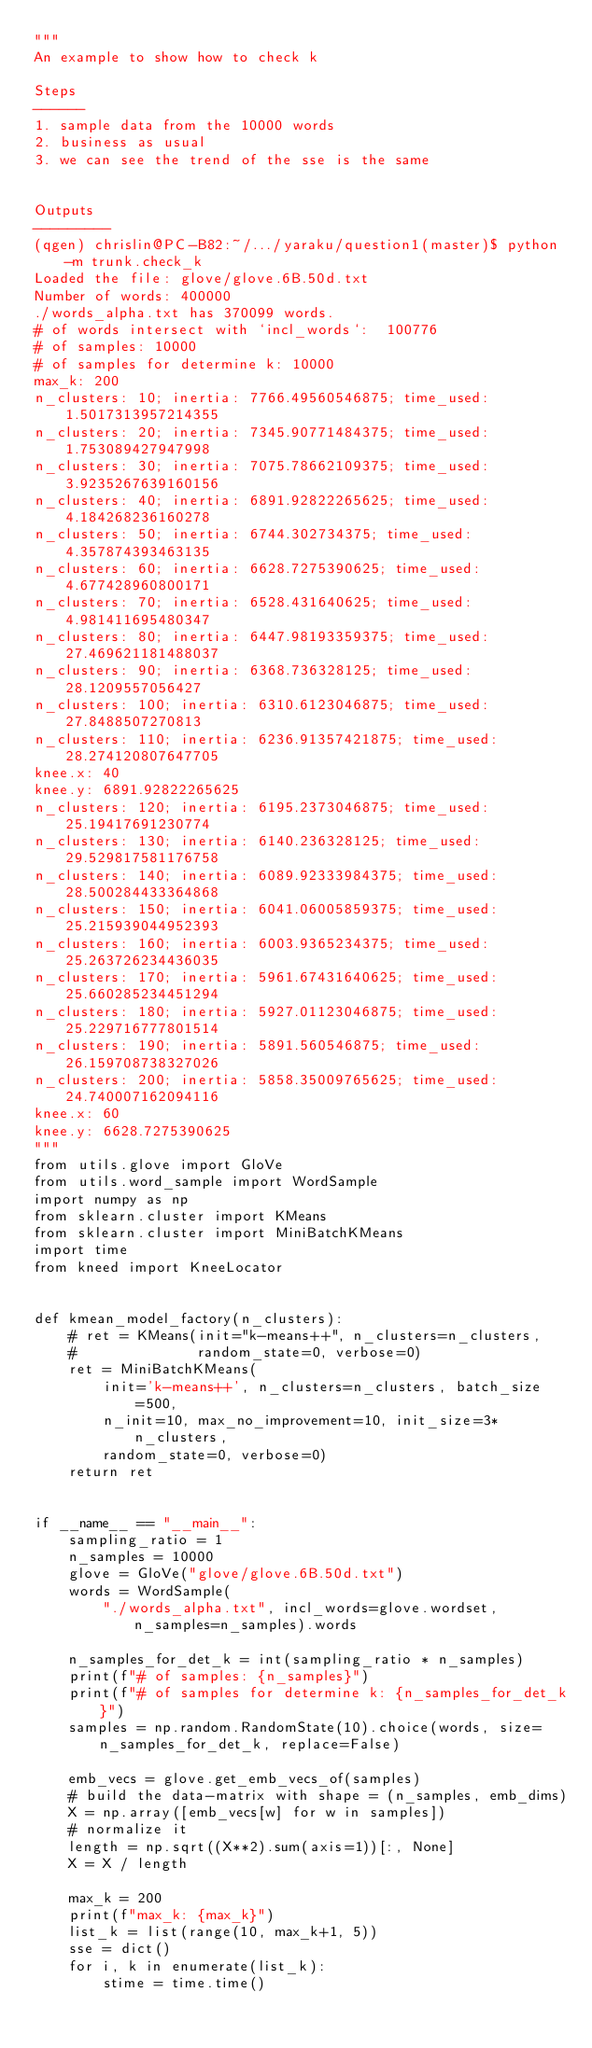<code> <loc_0><loc_0><loc_500><loc_500><_Python_>"""
An example to show how to check k

Steps
------
1. sample data from the 10000 words
2. business as usual
3. we can see the trend of the sse is the same


Outputs
---------
(qgen) chrislin@PC-B82:~/.../yaraku/question1(master)$ python -m trunk.check_k
Loaded the file: glove/glove.6B.50d.txt
Number of words: 400000
./words_alpha.txt has 370099 words.
# of words intersect with `incl_words`:  100776
# of samples: 10000
# of samples for determine k: 10000
max_k: 200
n_clusters: 10; inertia: 7766.49560546875; time_used: 1.5017313957214355
n_clusters: 20; inertia: 7345.90771484375; time_used: 1.753089427947998
n_clusters: 30; inertia: 7075.78662109375; time_used: 3.9235267639160156
n_clusters: 40; inertia: 6891.92822265625; time_used: 4.184268236160278
n_clusters: 50; inertia: 6744.302734375; time_used: 4.357874393463135
n_clusters: 60; inertia: 6628.7275390625; time_used: 4.677428960800171
n_clusters: 70; inertia: 6528.431640625; time_used: 4.981411695480347
n_clusters: 80; inertia: 6447.98193359375; time_used: 27.469621181488037
n_clusters: 90; inertia: 6368.736328125; time_used: 28.1209557056427
n_clusters: 100; inertia: 6310.6123046875; time_used: 27.8488507270813
n_clusters: 110; inertia: 6236.91357421875; time_used: 28.274120807647705
knee.x: 40
knee.y: 6891.92822265625
n_clusters: 120; inertia: 6195.2373046875; time_used: 25.19417691230774
n_clusters: 130; inertia: 6140.236328125; time_used: 29.529817581176758
n_clusters: 140; inertia: 6089.92333984375; time_used: 28.500284433364868
n_clusters: 150; inertia: 6041.06005859375; time_used: 25.215939044952393
n_clusters: 160; inertia: 6003.9365234375; time_used: 25.263726234436035
n_clusters: 170; inertia: 5961.67431640625; time_used: 25.660285234451294
n_clusters: 180; inertia: 5927.01123046875; time_used: 25.229716777801514
n_clusters: 190; inertia: 5891.560546875; time_used: 26.159708738327026
n_clusters: 200; inertia: 5858.35009765625; time_used: 24.740007162094116
knee.x: 60
knee.y: 6628.7275390625
"""
from utils.glove import GloVe
from utils.word_sample import WordSample
import numpy as np
from sklearn.cluster import KMeans
from sklearn.cluster import MiniBatchKMeans
import time
from kneed import KneeLocator


def kmean_model_factory(n_clusters):
    # ret = KMeans(init="k-means++", n_clusters=n_clusters,
    #              random_state=0, verbose=0)
    ret = MiniBatchKMeans(
        init='k-means++', n_clusters=n_clusters, batch_size=500,
        n_init=10, max_no_improvement=10, init_size=3*n_clusters,
        random_state=0, verbose=0)
    return ret


if __name__ == "__main__":
    sampling_ratio = 1
    n_samples = 10000
    glove = GloVe("glove/glove.6B.50d.txt")
    words = WordSample(
        "./words_alpha.txt", incl_words=glove.wordset, n_samples=n_samples).words

    n_samples_for_det_k = int(sampling_ratio * n_samples)
    print(f"# of samples: {n_samples}")
    print(f"# of samples for determine k: {n_samples_for_det_k}")
    samples = np.random.RandomState(10).choice(words, size=n_samples_for_det_k, replace=False)

    emb_vecs = glove.get_emb_vecs_of(samples)
    # build the data-matrix with shape = (n_samples, emb_dims)
    X = np.array([emb_vecs[w] for w in samples])
    # normalize it
    length = np.sqrt((X**2).sum(axis=1))[:, None]
    X = X / length

    max_k = 200
    print(f"max_k: {max_k}")
    list_k = list(range(10, max_k+1, 5))
    sse = dict()
    for i, k in enumerate(list_k):
        stime = time.time()</code> 